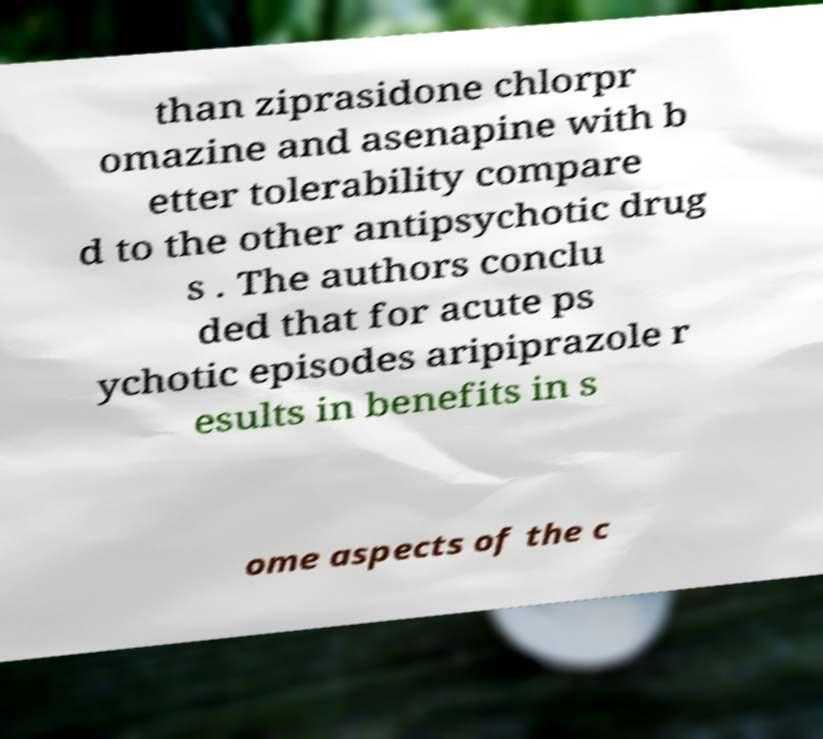Can you accurately transcribe the text from the provided image for me? than ziprasidone chlorpr omazine and asenapine with b etter tolerability compare d to the other antipsychotic drug s . The authors conclu ded that for acute ps ychotic episodes aripiprazole r esults in benefits in s ome aspects of the c 